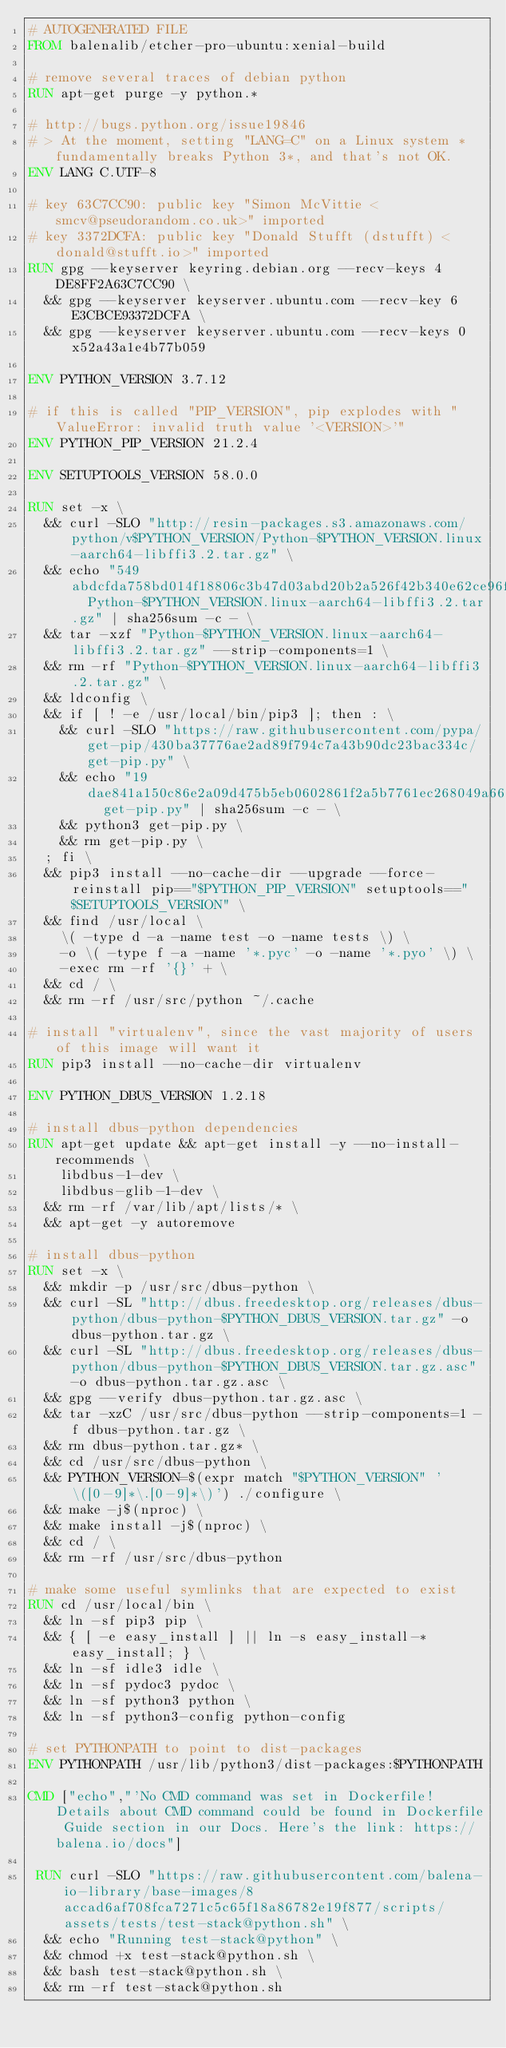<code> <loc_0><loc_0><loc_500><loc_500><_Dockerfile_># AUTOGENERATED FILE
FROM balenalib/etcher-pro-ubuntu:xenial-build

# remove several traces of debian python
RUN apt-get purge -y python.*

# http://bugs.python.org/issue19846
# > At the moment, setting "LANG=C" on a Linux system *fundamentally breaks Python 3*, and that's not OK.
ENV LANG C.UTF-8

# key 63C7CC90: public key "Simon McVittie <smcv@pseudorandom.co.uk>" imported
# key 3372DCFA: public key "Donald Stufft (dstufft) <donald@stufft.io>" imported
RUN gpg --keyserver keyring.debian.org --recv-keys 4DE8FF2A63C7CC90 \
	&& gpg --keyserver keyserver.ubuntu.com --recv-key 6E3CBCE93372DCFA \
	&& gpg --keyserver keyserver.ubuntu.com --recv-keys 0x52a43a1e4b77b059

ENV PYTHON_VERSION 3.7.12

# if this is called "PIP_VERSION", pip explodes with "ValueError: invalid truth value '<VERSION>'"
ENV PYTHON_PIP_VERSION 21.2.4

ENV SETUPTOOLS_VERSION 58.0.0

RUN set -x \
	&& curl -SLO "http://resin-packages.s3.amazonaws.com/python/v$PYTHON_VERSION/Python-$PYTHON_VERSION.linux-aarch64-libffi3.2.tar.gz" \
	&& echo "549abdcfda758bd014f18806c3b47d03abd20b2a526f42b340e62ce96f62ca3e  Python-$PYTHON_VERSION.linux-aarch64-libffi3.2.tar.gz" | sha256sum -c - \
	&& tar -xzf "Python-$PYTHON_VERSION.linux-aarch64-libffi3.2.tar.gz" --strip-components=1 \
	&& rm -rf "Python-$PYTHON_VERSION.linux-aarch64-libffi3.2.tar.gz" \
	&& ldconfig \
	&& if [ ! -e /usr/local/bin/pip3 ]; then : \
		&& curl -SLO "https://raw.githubusercontent.com/pypa/get-pip/430ba37776ae2ad89f794c7a43b90dc23bac334c/get-pip.py" \
		&& echo "19dae841a150c86e2a09d475b5eb0602861f2a5b7761ec268049a662dbd2bd0c  get-pip.py" | sha256sum -c - \
		&& python3 get-pip.py \
		&& rm get-pip.py \
	; fi \
	&& pip3 install --no-cache-dir --upgrade --force-reinstall pip=="$PYTHON_PIP_VERSION" setuptools=="$SETUPTOOLS_VERSION" \
	&& find /usr/local \
		\( -type d -a -name test -o -name tests \) \
		-o \( -type f -a -name '*.pyc' -o -name '*.pyo' \) \
		-exec rm -rf '{}' + \
	&& cd / \
	&& rm -rf /usr/src/python ~/.cache

# install "virtualenv", since the vast majority of users of this image will want it
RUN pip3 install --no-cache-dir virtualenv

ENV PYTHON_DBUS_VERSION 1.2.18

# install dbus-python dependencies 
RUN apt-get update && apt-get install -y --no-install-recommends \
		libdbus-1-dev \
		libdbus-glib-1-dev \
	&& rm -rf /var/lib/apt/lists/* \
	&& apt-get -y autoremove

# install dbus-python
RUN set -x \
	&& mkdir -p /usr/src/dbus-python \
	&& curl -SL "http://dbus.freedesktop.org/releases/dbus-python/dbus-python-$PYTHON_DBUS_VERSION.tar.gz" -o dbus-python.tar.gz \
	&& curl -SL "http://dbus.freedesktop.org/releases/dbus-python/dbus-python-$PYTHON_DBUS_VERSION.tar.gz.asc" -o dbus-python.tar.gz.asc \
	&& gpg --verify dbus-python.tar.gz.asc \
	&& tar -xzC /usr/src/dbus-python --strip-components=1 -f dbus-python.tar.gz \
	&& rm dbus-python.tar.gz* \
	&& cd /usr/src/dbus-python \
	&& PYTHON_VERSION=$(expr match "$PYTHON_VERSION" '\([0-9]*\.[0-9]*\)') ./configure \
	&& make -j$(nproc) \
	&& make install -j$(nproc) \
	&& cd / \
	&& rm -rf /usr/src/dbus-python

# make some useful symlinks that are expected to exist
RUN cd /usr/local/bin \
	&& ln -sf pip3 pip \
	&& { [ -e easy_install ] || ln -s easy_install-* easy_install; } \
	&& ln -sf idle3 idle \
	&& ln -sf pydoc3 pydoc \
	&& ln -sf python3 python \
	&& ln -sf python3-config python-config

# set PYTHONPATH to point to dist-packages
ENV PYTHONPATH /usr/lib/python3/dist-packages:$PYTHONPATH

CMD ["echo","'No CMD command was set in Dockerfile! Details about CMD command could be found in Dockerfile Guide section in our Docs. Here's the link: https://balena.io/docs"]

 RUN curl -SLO "https://raw.githubusercontent.com/balena-io-library/base-images/8accad6af708fca7271c5c65f18a86782e19f877/scripts/assets/tests/test-stack@python.sh" \
  && echo "Running test-stack@python" \
  && chmod +x test-stack@python.sh \
  && bash test-stack@python.sh \
  && rm -rf test-stack@python.sh 
</code> 